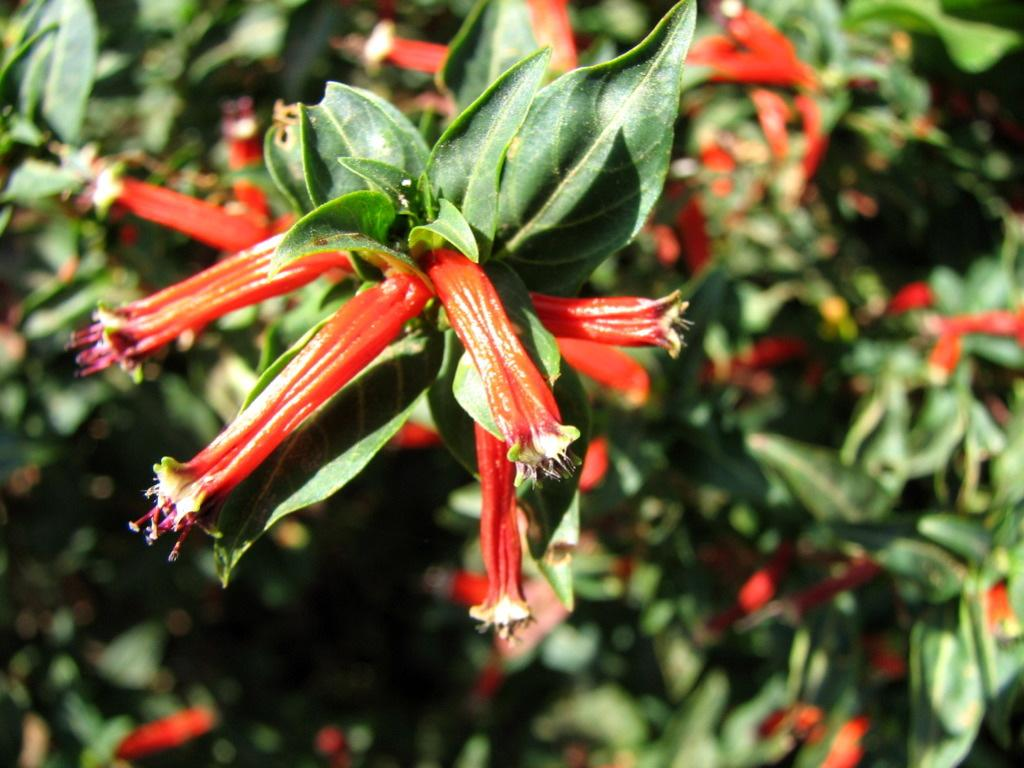What is the main subject in the center of the image? There are plants and flowers in the center of the image. What color are the plants and flowers? The plants and flowers are in red color. How many shoes are visible in the image? There are no shoes present in the image; it features plants and flowers. Is there any fire visible in the image? There is no fire present in the image. Can you see any eggs in the image? There are no eggs present in the image. 